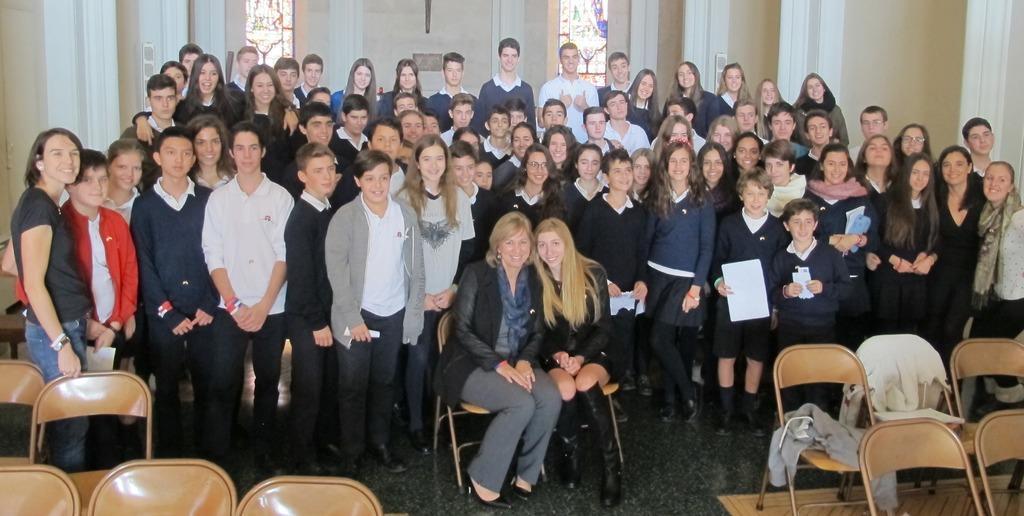Could you give a brief overview of what you see in this image? In this image I can see a group of people standing, in-front of them there are two people sitting in chairs, also there are so many empty chairs in the front. 